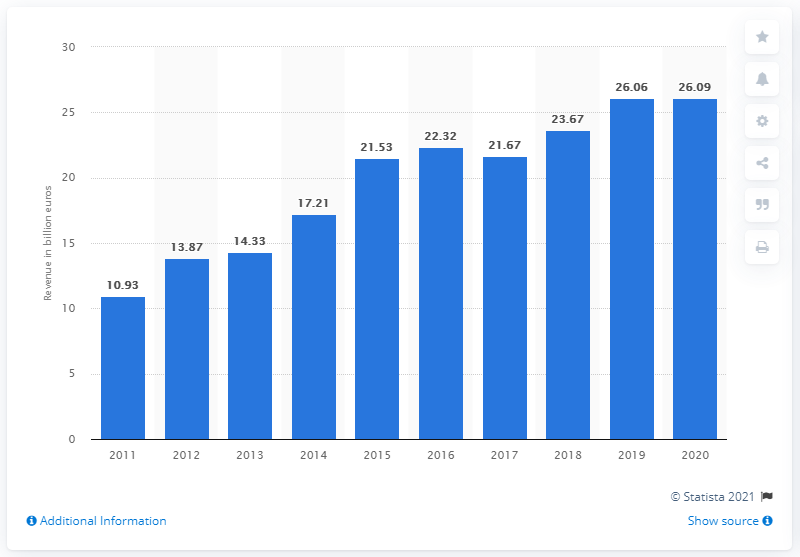Indicate a few pertinent items in this graphic. In 2011, Porsche's revenue was 10.93 billion. Porsche's revenue in 2019 was 26.09 billion USD. 